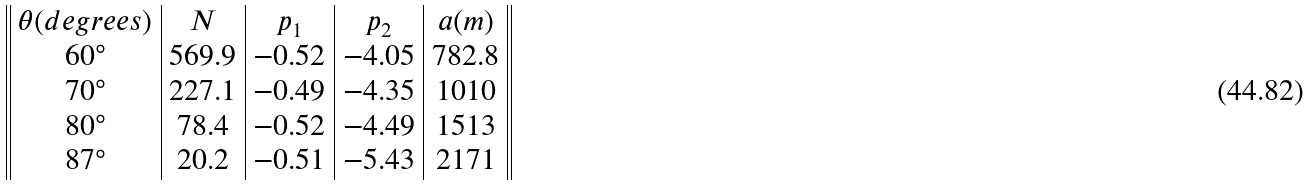<formula> <loc_0><loc_0><loc_500><loc_500>\begin{array} { | | c | c | c | c | c | | } \theta ( d e g r e e s ) & N & p _ { 1 } & p _ { 2 } & a ( m ) \\ 6 0 ^ { \circ } & 5 6 9 . 9 & - 0 . 5 2 & - 4 . 0 5 & 7 8 2 . 8 \\ 7 0 ^ { \circ } & 2 2 7 . 1 & - 0 . 4 9 & - 4 . 3 5 & 1 0 1 0 \\ 8 0 ^ { \circ } & 7 8 . 4 & - 0 . 5 2 & - 4 . 4 9 & 1 5 1 3 \\ 8 7 ^ { \circ } & 2 0 . 2 & - 0 . 5 1 & - 5 . 4 3 & 2 1 7 1 \\ \end{array}</formula> 